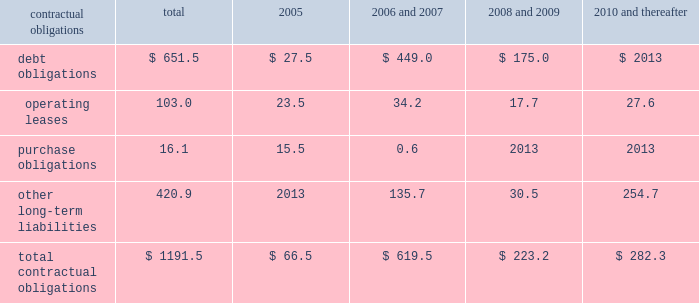Z i m m e r h o l d i n g s , i n c .
A n d s u b s i d i a r i e s 2 0 0 4 f o r m 1 0 - k contractual obligations the company has entered into contracts with various third parties in the normal course of business which will require future payments .
The table illustrates the company 2019s contractual obligations : 2006 2008 2010 and and and contractual obligations total 2005 2007 2009 thereafter .
Critical accounting estimates the financial results of the company are affected by the adequate provisions exist for income taxes for all periods and selection and application of accounting policies and methods .
Jurisdictions subject to review or audit .
Significant accounting policies which require management 2019s commitments and contingencies 2013 accruals for judgment are discussed below .
Product liability and other claims are established with excess inventory and instruments 2013 the company internal and external legal counsel based on current must determine as of each balance sheet date how much , if information and historical settlement information for claims , any , of its inventory may ultimately prove to be unsaleable or related fees and for claims incurred but not reported .
An unsaleable at its carrying cost .
Similarly , the company must actuarial model is used by the company to assist also determine if instruments on hand will be put to management in determining an appropriate level of accruals productive use or remain undeployed as a result of excess for product liability claims .
Historical patterns of claim loss supply .
Reserves are established to effectively adjust development over time are statistically analyzed to arrive at inventory and instruments to net realizable value .
To factors which are then applied to loss estimates in the determine the appropriate level of reserves , the company actuarial model .
The amounts established represent evaluates current stock levels in relation to historical and management 2019s best estimate of the ultimate costs that it will expected patterns of demand for all of its products and incur under the various contingencies .
Instrument systems and components .
The basis for the goodwill and intangible assets 2013 the company determination is generally the same for all inventory and evaluates the carrying value of goodwill and indefinite life instrument items and categories except for work-in-progress intangible assets annually , or whenever events or inventory , which is recorded at cost .
Obsolete or circumstances indicate the carrying value may not be discontinued items are generally destroyed and completely recoverable .
The company evaluates the carrying value of written off .
Management evaluates the need for changes to finite life intangible assets whenever events or circumstances valuation reserves based on market conditions , competitive indicate the carrying value may not be recoverable .
Offerings and other factors on a regular basis .
Significant assumptions are required to estimate the fair income taxes 2013 the company estimates income tax value of goodwill and intangible assets , most notably expense and income tax liabilities and assets by taxable estimated future cash flows generated by these assets .
Jurisdiction .
Realization of deferred tax assets in each taxable changes to these assumptions could result in the company jurisdiction is dependent on the company 2019s ability to being required to record impairment charges on these assets .
Generate future taxable income sufficient to realize the benefits .
The company evaluates deferred tax assets on an recent accounting pronouncements ongoing basis and provides valuation allowances if it is information about recent accounting pronouncements is determined to be 2018 2018more likely than not 2019 2019 that the deferred tax included in note 2 to the consolidated financial statements , benefit will not be realized .
Federal income taxes are which are included herein under item 8 .
Provided on the portion of the income of foreign subsidiaries that is expected to be remitted to the u.s .
The company operates within numerous taxing jurisdictions .
The company is subject to regulatory review or audit in virtually all of those jurisdictions and those reviews and audits may require extended periods of time to resolve .
The company makes use of all available information and makes reasoned judgments regarding matters requiring interpretation in establishing tax expense , liabilities and reserves .
The company believes .
What percent of total contractual obligations is debt obligations? 
Computations: (651.5 / 1191.5)
Answer: 0.54679. 